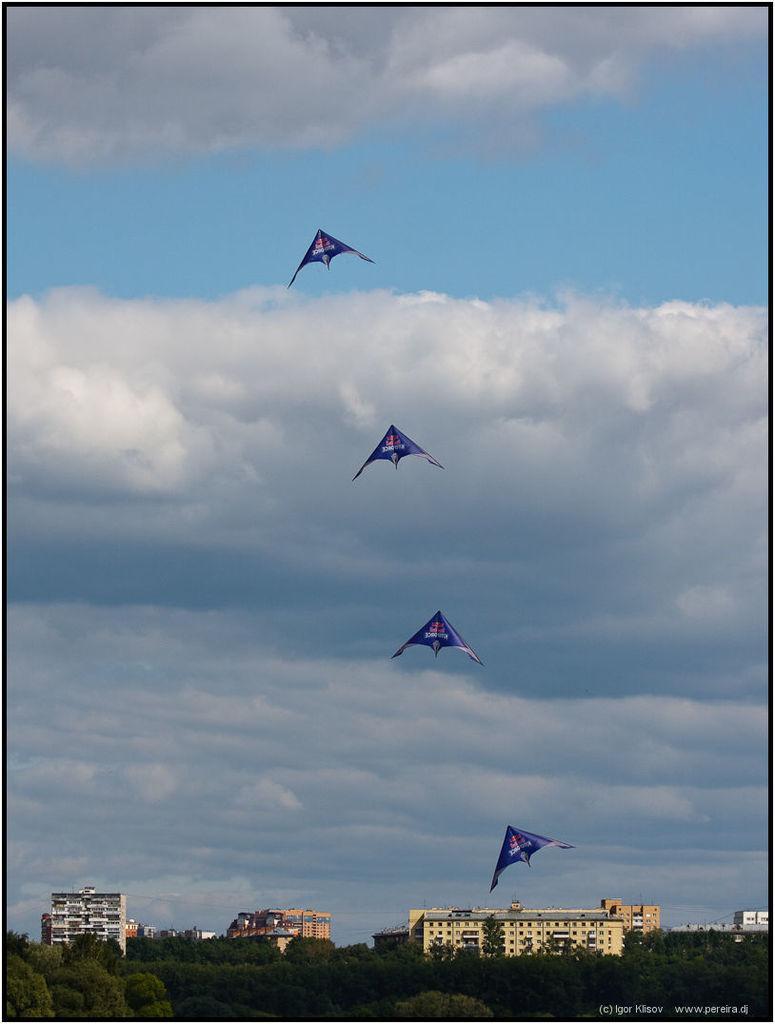How would you summarize this image in a sentence or two? In this image, we can see a four kites are flying in the sky. At the bottom, we can see buildings, trees. Background there is a cloudy sky. At the bottom of the image, we can see a watermark. 